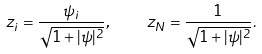Convert formula to latex. <formula><loc_0><loc_0><loc_500><loc_500>z _ { i } = \frac { \psi _ { i } } { \sqrt { 1 + | \psi | ^ { 2 } } } , \quad z _ { N } = \frac { 1 } { \sqrt { 1 + | \psi | ^ { 2 } } } .</formula> 